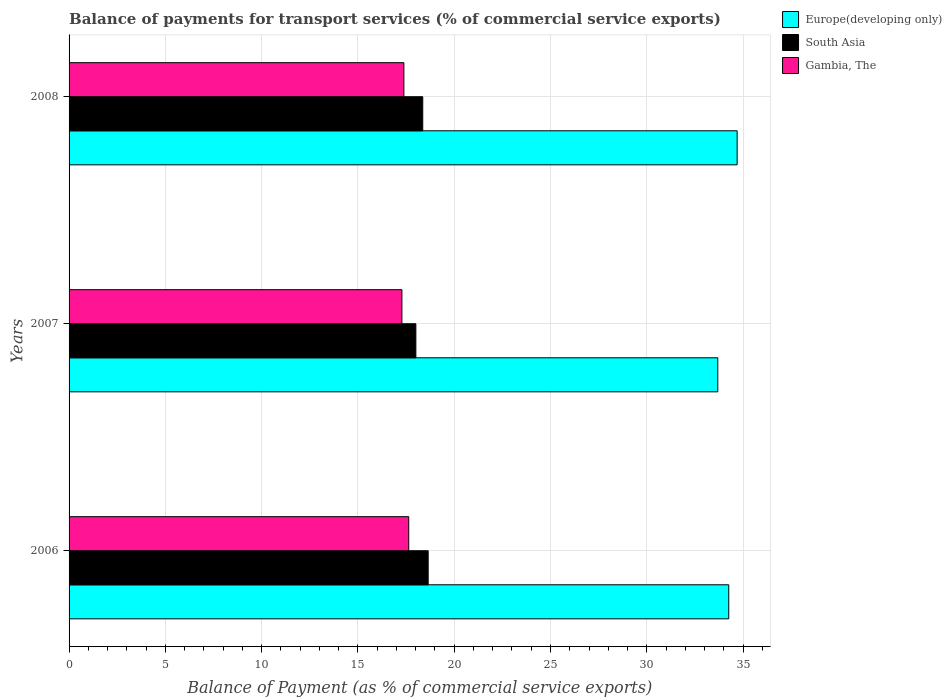How many different coloured bars are there?
Offer a terse response. 3. Are the number of bars on each tick of the Y-axis equal?
Offer a very short reply. Yes. How many bars are there on the 1st tick from the bottom?
Offer a very short reply. 3. In how many cases, is the number of bars for a given year not equal to the number of legend labels?
Provide a short and direct response. 0. What is the balance of payments for transport services in Gambia, The in 2008?
Offer a terse response. 17.39. Across all years, what is the maximum balance of payments for transport services in Europe(developing only)?
Offer a very short reply. 34.69. Across all years, what is the minimum balance of payments for transport services in South Asia?
Your answer should be compact. 18.01. In which year was the balance of payments for transport services in Gambia, The minimum?
Offer a terse response. 2007. What is the total balance of payments for transport services in South Asia in the graph?
Give a very brief answer. 55.02. What is the difference between the balance of payments for transport services in South Asia in 2006 and that in 2007?
Ensure brevity in your answer.  0.64. What is the difference between the balance of payments for transport services in South Asia in 2006 and the balance of payments for transport services in Europe(developing only) in 2008?
Your answer should be compact. -16.04. What is the average balance of payments for transport services in Gambia, The per year?
Your answer should be compact. 17.44. In the year 2007, what is the difference between the balance of payments for transport services in South Asia and balance of payments for transport services in Europe(developing only)?
Provide a succinct answer. -15.68. What is the ratio of the balance of payments for transport services in South Asia in 2006 to that in 2008?
Your response must be concise. 1.02. Is the balance of payments for transport services in South Asia in 2007 less than that in 2008?
Your answer should be very brief. Yes. What is the difference between the highest and the second highest balance of payments for transport services in Europe(developing only)?
Your answer should be very brief. 0.44. What is the difference between the highest and the lowest balance of payments for transport services in Gambia, The?
Make the answer very short. 0.35. In how many years, is the balance of payments for transport services in South Asia greater than the average balance of payments for transport services in South Asia taken over all years?
Give a very brief answer. 2. Is the sum of the balance of payments for transport services in Europe(developing only) in 2007 and 2008 greater than the maximum balance of payments for transport services in South Asia across all years?
Offer a very short reply. Yes. What does the 2nd bar from the top in 2006 represents?
Give a very brief answer. South Asia. Is it the case that in every year, the sum of the balance of payments for transport services in South Asia and balance of payments for transport services in Gambia, The is greater than the balance of payments for transport services in Europe(developing only)?
Make the answer very short. Yes. Are all the bars in the graph horizontal?
Offer a very short reply. Yes. How many years are there in the graph?
Make the answer very short. 3. What is the difference between two consecutive major ticks on the X-axis?
Keep it short and to the point. 5. Does the graph contain any zero values?
Your answer should be compact. No. How many legend labels are there?
Ensure brevity in your answer.  3. How are the legend labels stacked?
Give a very brief answer. Vertical. What is the title of the graph?
Provide a succinct answer. Balance of payments for transport services (% of commercial service exports). Does "Micronesia" appear as one of the legend labels in the graph?
Provide a succinct answer. No. What is the label or title of the X-axis?
Offer a terse response. Balance of Payment (as % of commercial service exports). What is the label or title of the Y-axis?
Offer a terse response. Years. What is the Balance of Payment (as % of commercial service exports) in Europe(developing only) in 2006?
Ensure brevity in your answer.  34.26. What is the Balance of Payment (as % of commercial service exports) of South Asia in 2006?
Make the answer very short. 18.65. What is the Balance of Payment (as % of commercial service exports) in Gambia, The in 2006?
Your answer should be very brief. 17.64. What is the Balance of Payment (as % of commercial service exports) of Europe(developing only) in 2007?
Provide a succinct answer. 33.69. What is the Balance of Payment (as % of commercial service exports) of South Asia in 2007?
Provide a succinct answer. 18.01. What is the Balance of Payment (as % of commercial service exports) of Gambia, The in 2007?
Give a very brief answer. 17.28. What is the Balance of Payment (as % of commercial service exports) of Europe(developing only) in 2008?
Offer a very short reply. 34.69. What is the Balance of Payment (as % of commercial service exports) of South Asia in 2008?
Provide a succinct answer. 18.37. What is the Balance of Payment (as % of commercial service exports) of Gambia, The in 2008?
Your answer should be very brief. 17.39. Across all years, what is the maximum Balance of Payment (as % of commercial service exports) in Europe(developing only)?
Make the answer very short. 34.69. Across all years, what is the maximum Balance of Payment (as % of commercial service exports) of South Asia?
Your answer should be compact. 18.65. Across all years, what is the maximum Balance of Payment (as % of commercial service exports) of Gambia, The?
Ensure brevity in your answer.  17.64. Across all years, what is the minimum Balance of Payment (as % of commercial service exports) of Europe(developing only)?
Your response must be concise. 33.69. Across all years, what is the minimum Balance of Payment (as % of commercial service exports) in South Asia?
Your response must be concise. 18.01. Across all years, what is the minimum Balance of Payment (as % of commercial service exports) of Gambia, The?
Ensure brevity in your answer.  17.28. What is the total Balance of Payment (as % of commercial service exports) of Europe(developing only) in the graph?
Provide a succinct answer. 102.64. What is the total Balance of Payment (as % of commercial service exports) of South Asia in the graph?
Ensure brevity in your answer.  55.02. What is the total Balance of Payment (as % of commercial service exports) of Gambia, The in the graph?
Your answer should be very brief. 52.31. What is the difference between the Balance of Payment (as % of commercial service exports) of Europe(developing only) in 2006 and that in 2007?
Offer a very short reply. 0.57. What is the difference between the Balance of Payment (as % of commercial service exports) of South Asia in 2006 and that in 2007?
Give a very brief answer. 0.64. What is the difference between the Balance of Payment (as % of commercial service exports) in Gambia, The in 2006 and that in 2007?
Offer a terse response. 0.35. What is the difference between the Balance of Payment (as % of commercial service exports) of Europe(developing only) in 2006 and that in 2008?
Provide a succinct answer. -0.44. What is the difference between the Balance of Payment (as % of commercial service exports) of South Asia in 2006 and that in 2008?
Provide a short and direct response. 0.28. What is the difference between the Balance of Payment (as % of commercial service exports) in Gambia, The in 2006 and that in 2008?
Your response must be concise. 0.25. What is the difference between the Balance of Payment (as % of commercial service exports) in Europe(developing only) in 2007 and that in 2008?
Make the answer very short. -1. What is the difference between the Balance of Payment (as % of commercial service exports) in South Asia in 2007 and that in 2008?
Your response must be concise. -0.36. What is the difference between the Balance of Payment (as % of commercial service exports) in Gambia, The in 2007 and that in 2008?
Your answer should be very brief. -0.1. What is the difference between the Balance of Payment (as % of commercial service exports) in Europe(developing only) in 2006 and the Balance of Payment (as % of commercial service exports) in South Asia in 2007?
Give a very brief answer. 16.25. What is the difference between the Balance of Payment (as % of commercial service exports) in Europe(developing only) in 2006 and the Balance of Payment (as % of commercial service exports) in Gambia, The in 2007?
Provide a short and direct response. 16.97. What is the difference between the Balance of Payment (as % of commercial service exports) in South Asia in 2006 and the Balance of Payment (as % of commercial service exports) in Gambia, The in 2007?
Give a very brief answer. 1.36. What is the difference between the Balance of Payment (as % of commercial service exports) of Europe(developing only) in 2006 and the Balance of Payment (as % of commercial service exports) of South Asia in 2008?
Ensure brevity in your answer.  15.89. What is the difference between the Balance of Payment (as % of commercial service exports) in Europe(developing only) in 2006 and the Balance of Payment (as % of commercial service exports) in Gambia, The in 2008?
Give a very brief answer. 16.87. What is the difference between the Balance of Payment (as % of commercial service exports) of South Asia in 2006 and the Balance of Payment (as % of commercial service exports) of Gambia, The in 2008?
Provide a short and direct response. 1.26. What is the difference between the Balance of Payment (as % of commercial service exports) in Europe(developing only) in 2007 and the Balance of Payment (as % of commercial service exports) in South Asia in 2008?
Keep it short and to the point. 15.32. What is the difference between the Balance of Payment (as % of commercial service exports) in Europe(developing only) in 2007 and the Balance of Payment (as % of commercial service exports) in Gambia, The in 2008?
Offer a very short reply. 16.3. What is the difference between the Balance of Payment (as % of commercial service exports) in South Asia in 2007 and the Balance of Payment (as % of commercial service exports) in Gambia, The in 2008?
Your answer should be very brief. 0.62. What is the average Balance of Payment (as % of commercial service exports) of Europe(developing only) per year?
Keep it short and to the point. 34.21. What is the average Balance of Payment (as % of commercial service exports) in South Asia per year?
Keep it short and to the point. 18.34. What is the average Balance of Payment (as % of commercial service exports) of Gambia, The per year?
Keep it short and to the point. 17.44. In the year 2006, what is the difference between the Balance of Payment (as % of commercial service exports) in Europe(developing only) and Balance of Payment (as % of commercial service exports) in South Asia?
Keep it short and to the point. 15.61. In the year 2006, what is the difference between the Balance of Payment (as % of commercial service exports) of Europe(developing only) and Balance of Payment (as % of commercial service exports) of Gambia, The?
Offer a very short reply. 16.62. In the year 2006, what is the difference between the Balance of Payment (as % of commercial service exports) of South Asia and Balance of Payment (as % of commercial service exports) of Gambia, The?
Make the answer very short. 1.01. In the year 2007, what is the difference between the Balance of Payment (as % of commercial service exports) of Europe(developing only) and Balance of Payment (as % of commercial service exports) of South Asia?
Offer a very short reply. 15.68. In the year 2007, what is the difference between the Balance of Payment (as % of commercial service exports) in Europe(developing only) and Balance of Payment (as % of commercial service exports) in Gambia, The?
Offer a very short reply. 16.4. In the year 2007, what is the difference between the Balance of Payment (as % of commercial service exports) in South Asia and Balance of Payment (as % of commercial service exports) in Gambia, The?
Your response must be concise. 0.72. In the year 2008, what is the difference between the Balance of Payment (as % of commercial service exports) of Europe(developing only) and Balance of Payment (as % of commercial service exports) of South Asia?
Provide a short and direct response. 16.33. In the year 2008, what is the difference between the Balance of Payment (as % of commercial service exports) in Europe(developing only) and Balance of Payment (as % of commercial service exports) in Gambia, The?
Your answer should be very brief. 17.31. In the year 2008, what is the difference between the Balance of Payment (as % of commercial service exports) in South Asia and Balance of Payment (as % of commercial service exports) in Gambia, The?
Your answer should be very brief. 0.98. What is the ratio of the Balance of Payment (as % of commercial service exports) in Europe(developing only) in 2006 to that in 2007?
Make the answer very short. 1.02. What is the ratio of the Balance of Payment (as % of commercial service exports) in South Asia in 2006 to that in 2007?
Give a very brief answer. 1.04. What is the ratio of the Balance of Payment (as % of commercial service exports) in Gambia, The in 2006 to that in 2007?
Make the answer very short. 1.02. What is the ratio of the Balance of Payment (as % of commercial service exports) of Europe(developing only) in 2006 to that in 2008?
Provide a short and direct response. 0.99. What is the ratio of the Balance of Payment (as % of commercial service exports) in South Asia in 2006 to that in 2008?
Provide a succinct answer. 1.02. What is the ratio of the Balance of Payment (as % of commercial service exports) of Gambia, The in 2006 to that in 2008?
Give a very brief answer. 1.01. What is the ratio of the Balance of Payment (as % of commercial service exports) in Europe(developing only) in 2007 to that in 2008?
Keep it short and to the point. 0.97. What is the ratio of the Balance of Payment (as % of commercial service exports) of South Asia in 2007 to that in 2008?
Your answer should be compact. 0.98. What is the difference between the highest and the second highest Balance of Payment (as % of commercial service exports) of Europe(developing only)?
Keep it short and to the point. 0.44. What is the difference between the highest and the second highest Balance of Payment (as % of commercial service exports) in South Asia?
Provide a succinct answer. 0.28. What is the difference between the highest and the second highest Balance of Payment (as % of commercial service exports) of Gambia, The?
Make the answer very short. 0.25. What is the difference between the highest and the lowest Balance of Payment (as % of commercial service exports) of Europe(developing only)?
Your answer should be compact. 1. What is the difference between the highest and the lowest Balance of Payment (as % of commercial service exports) of South Asia?
Provide a short and direct response. 0.64. What is the difference between the highest and the lowest Balance of Payment (as % of commercial service exports) of Gambia, The?
Give a very brief answer. 0.35. 